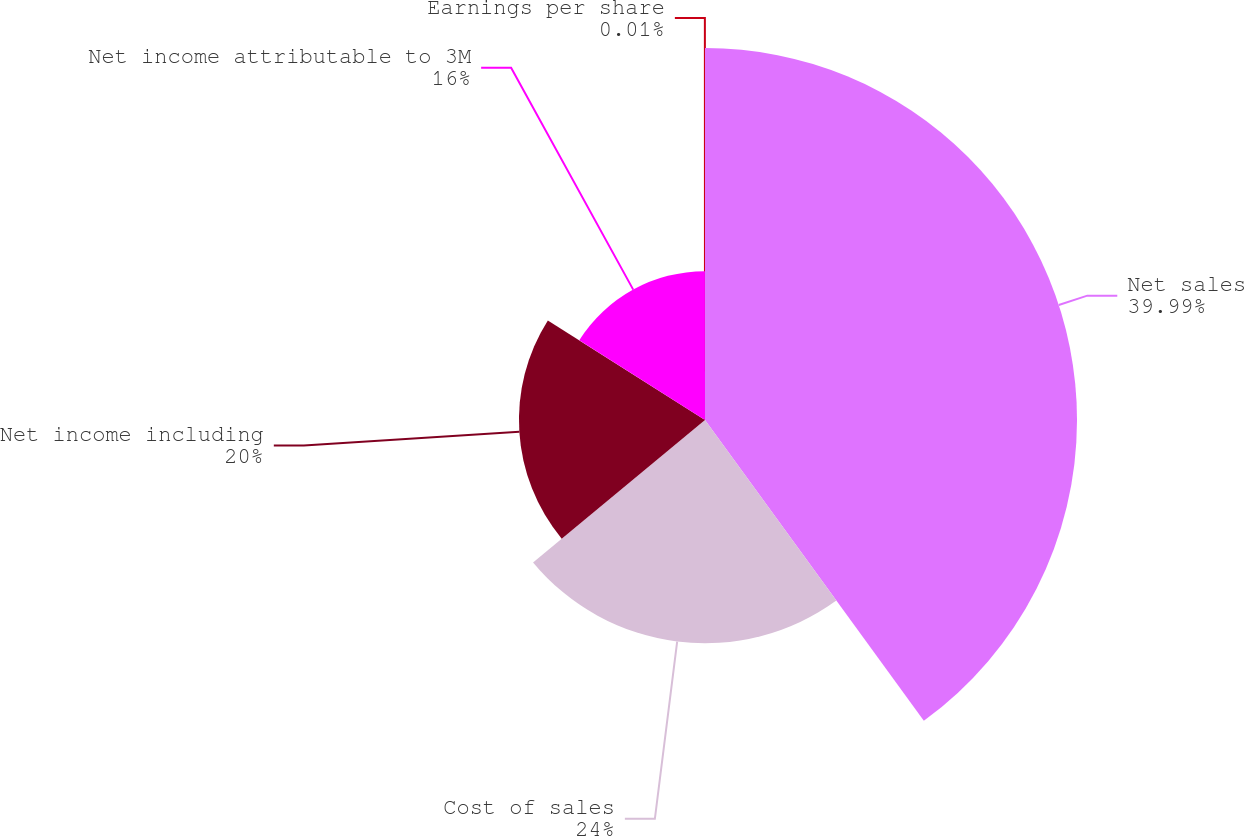<chart> <loc_0><loc_0><loc_500><loc_500><pie_chart><fcel>Net sales<fcel>Cost of sales<fcel>Net income including<fcel>Net income attributable to 3M<fcel>Earnings per share<nl><fcel>39.99%<fcel>24.0%<fcel>20.0%<fcel>16.0%<fcel>0.01%<nl></chart> 